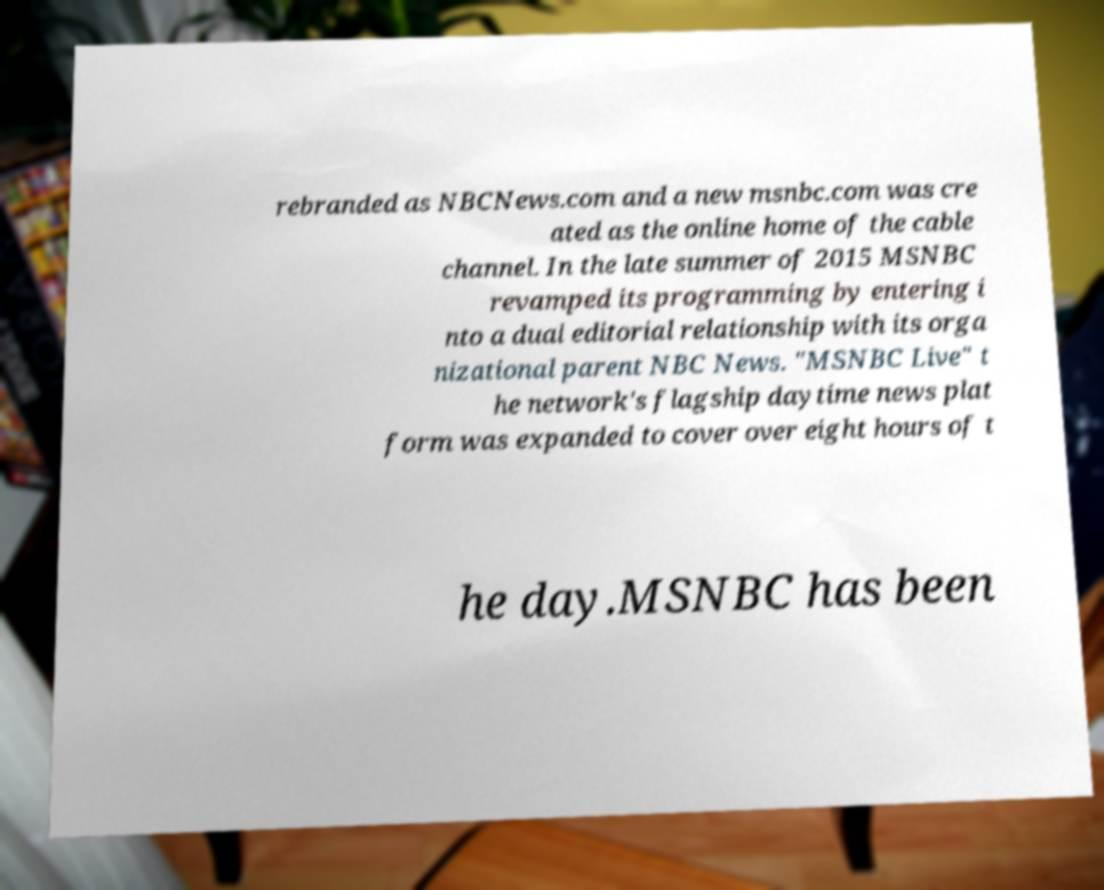What messages or text are displayed in this image? I need them in a readable, typed format. rebranded as NBCNews.com and a new msnbc.com was cre ated as the online home of the cable channel. In the late summer of 2015 MSNBC revamped its programming by entering i nto a dual editorial relationship with its orga nizational parent NBC News. "MSNBC Live" t he network's flagship daytime news plat form was expanded to cover over eight hours of t he day.MSNBC has been 